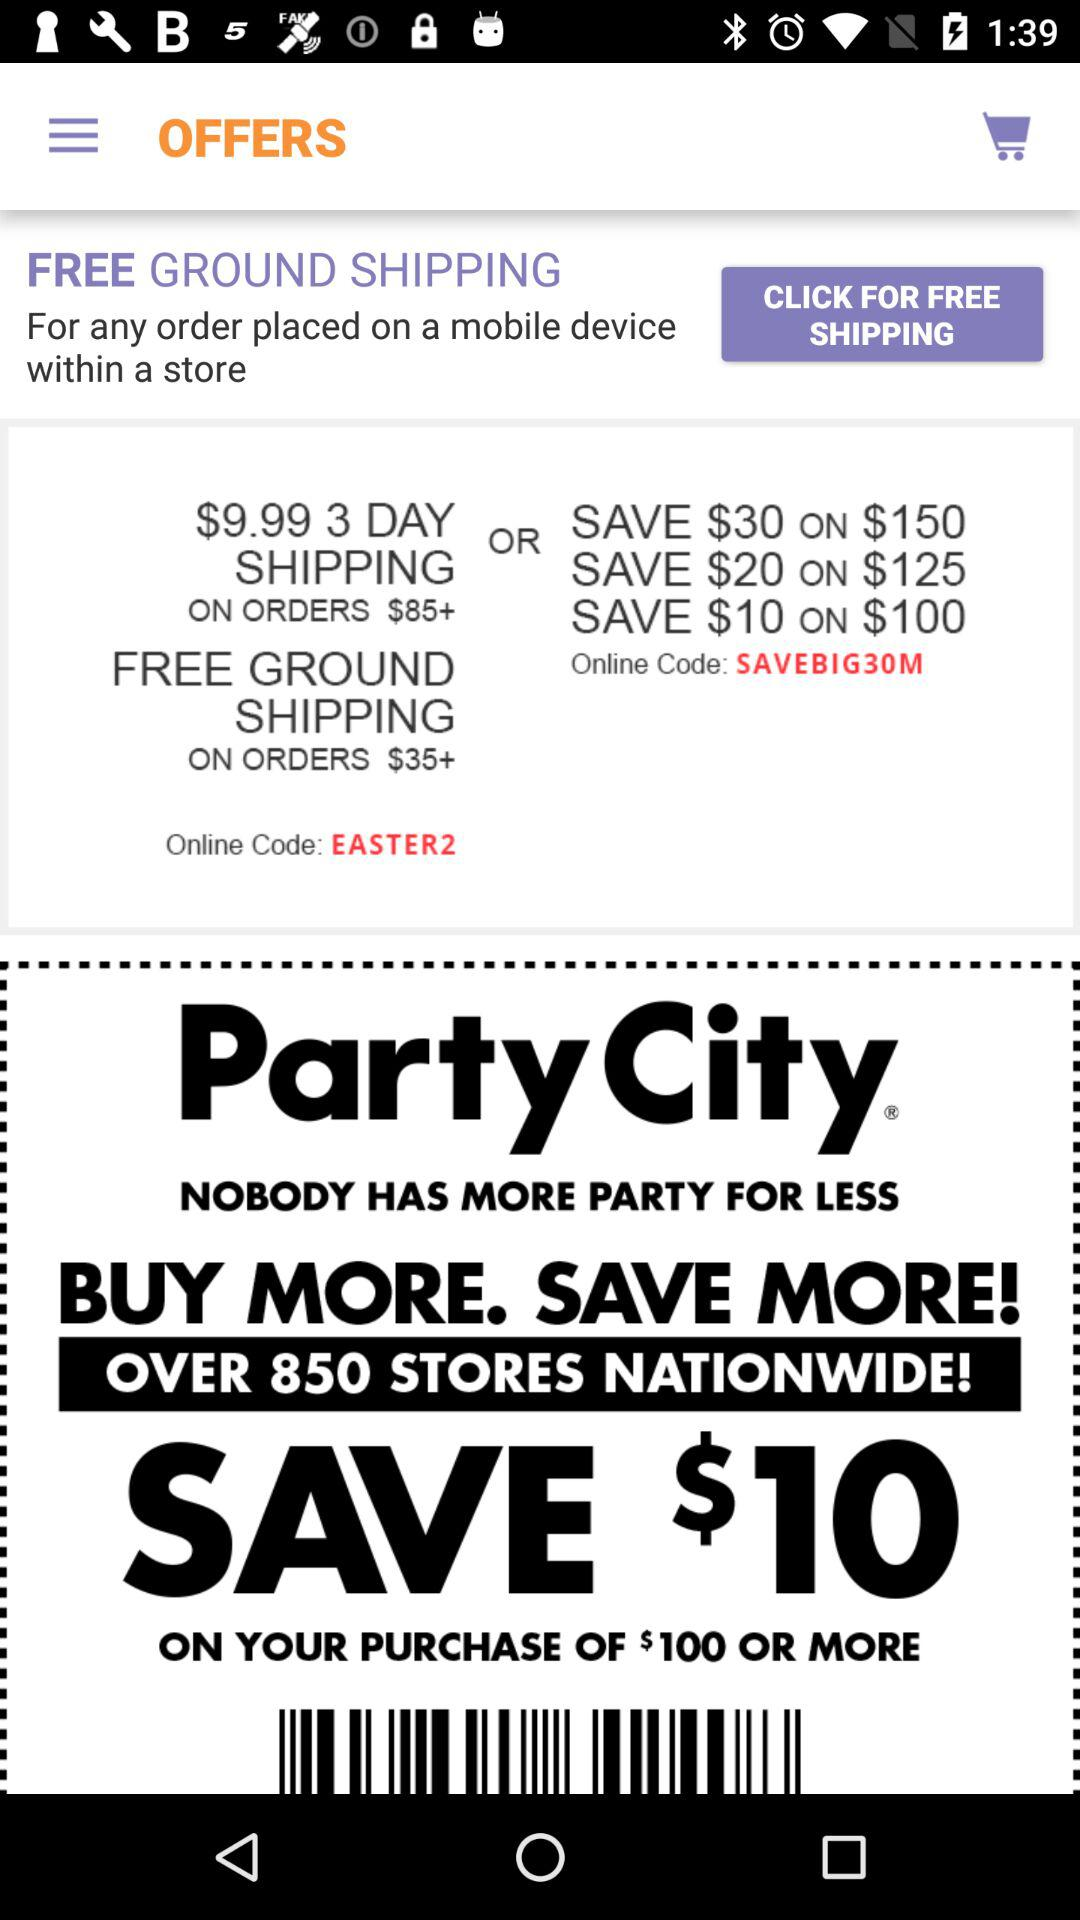How much is the 3 day shipping price on orders above $85? The price is $9.99. 